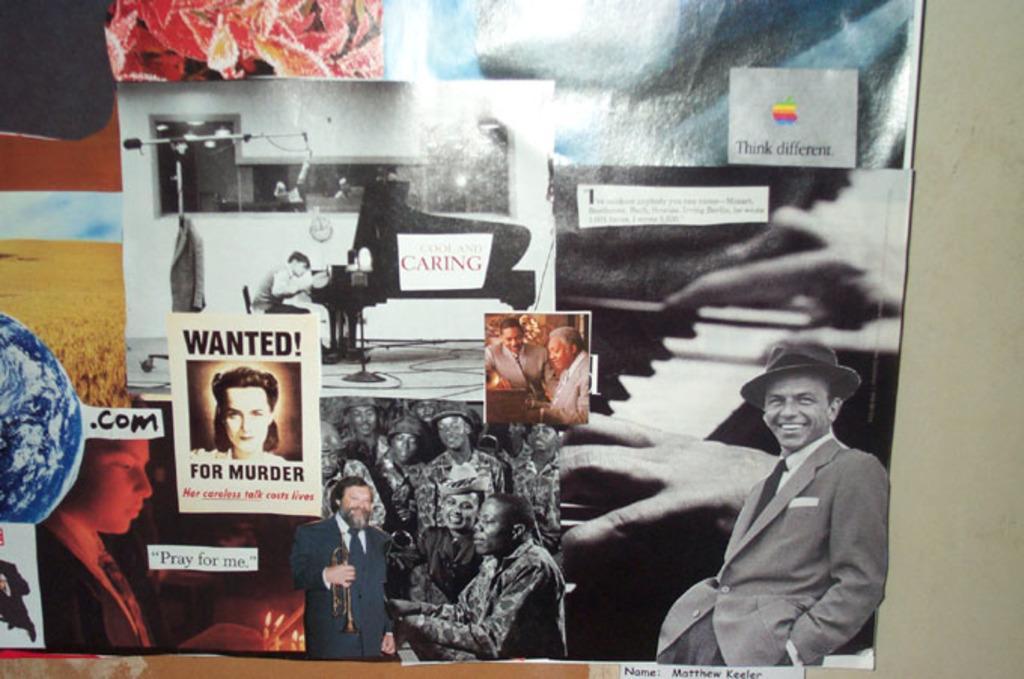Can you describe this image briefly? There are different posters having different images pasted on a wall. And the background is gray in color. 